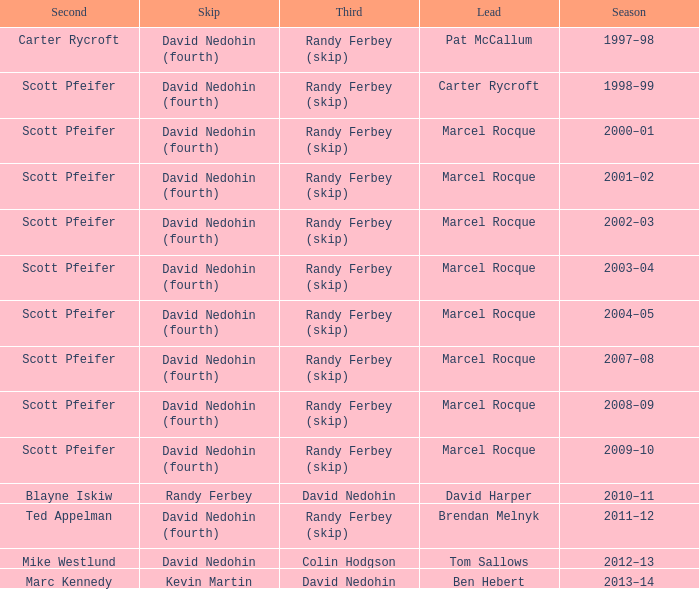Which Skip has a Season of 2002–03? David Nedohin (fourth). Help me parse the entirety of this table. {'header': ['Second', 'Skip', 'Third', 'Lead', 'Season'], 'rows': [['Carter Rycroft', 'David Nedohin (fourth)', 'Randy Ferbey (skip)', 'Pat McCallum', '1997–98'], ['Scott Pfeifer', 'David Nedohin (fourth)', 'Randy Ferbey (skip)', 'Carter Rycroft', '1998–99'], ['Scott Pfeifer', 'David Nedohin (fourth)', 'Randy Ferbey (skip)', 'Marcel Rocque', '2000–01'], ['Scott Pfeifer', 'David Nedohin (fourth)', 'Randy Ferbey (skip)', 'Marcel Rocque', '2001–02'], ['Scott Pfeifer', 'David Nedohin (fourth)', 'Randy Ferbey (skip)', 'Marcel Rocque', '2002–03'], ['Scott Pfeifer', 'David Nedohin (fourth)', 'Randy Ferbey (skip)', 'Marcel Rocque', '2003–04'], ['Scott Pfeifer', 'David Nedohin (fourth)', 'Randy Ferbey (skip)', 'Marcel Rocque', '2004–05'], ['Scott Pfeifer', 'David Nedohin (fourth)', 'Randy Ferbey (skip)', 'Marcel Rocque', '2007–08'], ['Scott Pfeifer', 'David Nedohin (fourth)', 'Randy Ferbey (skip)', 'Marcel Rocque', '2008–09'], ['Scott Pfeifer', 'David Nedohin (fourth)', 'Randy Ferbey (skip)', 'Marcel Rocque', '2009–10'], ['Blayne Iskiw', 'Randy Ferbey', 'David Nedohin', 'David Harper', '2010–11'], ['Ted Appelman', 'David Nedohin (fourth)', 'Randy Ferbey (skip)', 'Brendan Melnyk', '2011–12'], ['Mike Westlund', 'David Nedohin', 'Colin Hodgson', 'Tom Sallows', '2012–13'], ['Marc Kennedy', 'Kevin Martin', 'David Nedohin', 'Ben Hebert', '2013–14']]} 